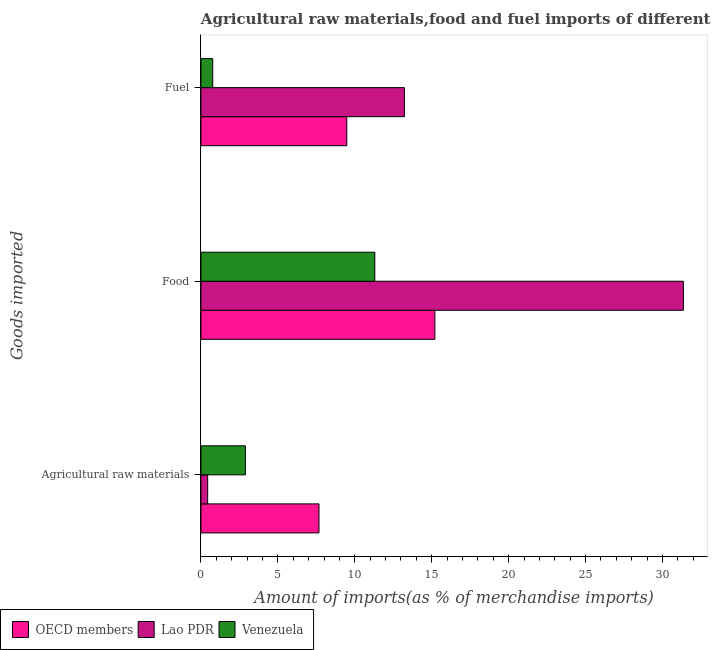How many different coloured bars are there?
Give a very brief answer. 3. How many groups of bars are there?
Give a very brief answer. 3. Are the number of bars per tick equal to the number of legend labels?
Ensure brevity in your answer.  Yes. How many bars are there on the 1st tick from the bottom?
Provide a short and direct response. 3. What is the label of the 1st group of bars from the top?
Provide a short and direct response. Fuel. What is the percentage of raw materials imports in OECD members?
Give a very brief answer. 7.67. Across all countries, what is the maximum percentage of food imports?
Keep it short and to the point. 31.35. Across all countries, what is the minimum percentage of raw materials imports?
Ensure brevity in your answer.  0.44. In which country was the percentage of food imports maximum?
Give a very brief answer. Lao PDR. In which country was the percentage of fuel imports minimum?
Make the answer very short. Venezuela. What is the total percentage of food imports in the graph?
Keep it short and to the point. 57.86. What is the difference between the percentage of fuel imports in Venezuela and that in Lao PDR?
Your answer should be very brief. -12.46. What is the difference between the percentage of raw materials imports in Venezuela and the percentage of fuel imports in OECD members?
Your answer should be compact. -6.59. What is the average percentage of raw materials imports per country?
Make the answer very short. 3.67. What is the difference between the percentage of raw materials imports and percentage of fuel imports in Lao PDR?
Your answer should be very brief. -12.79. In how many countries, is the percentage of food imports greater than 30 %?
Give a very brief answer. 1. What is the ratio of the percentage of food imports in OECD members to that in Venezuela?
Make the answer very short. 1.35. Is the difference between the percentage of fuel imports in Lao PDR and OECD members greater than the difference between the percentage of food imports in Lao PDR and OECD members?
Offer a very short reply. No. What is the difference between the highest and the second highest percentage of fuel imports?
Your answer should be compact. 3.75. What is the difference between the highest and the lowest percentage of fuel imports?
Your response must be concise. 12.46. In how many countries, is the percentage of food imports greater than the average percentage of food imports taken over all countries?
Offer a very short reply. 1. What does the 3rd bar from the bottom in Fuel represents?
Offer a very short reply. Venezuela. Is it the case that in every country, the sum of the percentage of raw materials imports and percentage of food imports is greater than the percentage of fuel imports?
Ensure brevity in your answer.  Yes. How many bars are there?
Your answer should be very brief. 9. Are the values on the major ticks of X-axis written in scientific E-notation?
Your answer should be compact. No. Does the graph contain any zero values?
Provide a short and direct response. No. Does the graph contain grids?
Give a very brief answer. No. How are the legend labels stacked?
Give a very brief answer. Horizontal. What is the title of the graph?
Give a very brief answer. Agricultural raw materials,food and fuel imports of different countries in 1969. Does "Ghana" appear as one of the legend labels in the graph?
Your answer should be compact. No. What is the label or title of the X-axis?
Your answer should be very brief. Amount of imports(as % of merchandise imports). What is the label or title of the Y-axis?
Provide a short and direct response. Goods imported. What is the Amount of imports(as % of merchandise imports) in OECD members in Agricultural raw materials?
Provide a succinct answer. 7.67. What is the Amount of imports(as % of merchandise imports) of Lao PDR in Agricultural raw materials?
Ensure brevity in your answer.  0.44. What is the Amount of imports(as % of merchandise imports) of Venezuela in Agricultural raw materials?
Keep it short and to the point. 2.89. What is the Amount of imports(as % of merchandise imports) of OECD members in Food?
Your answer should be compact. 15.21. What is the Amount of imports(as % of merchandise imports) in Lao PDR in Food?
Your answer should be very brief. 31.35. What is the Amount of imports(as % of merchandise imports) in Venezuela in Food?
Ensure brevity in your answer.  11.3. What is the Amount of imports(as % of merchandise imports) of OECD members in Fuel?
Your answer should be very brief. 9.48. What is the Amount of imports(as % of merchandise imports) in Lao PDR in Fuel?
Give a very brief answer. 13.23. What is the Amount of imports(as % of merchandise imports) in Venezuela in Fuel?
Make the answer very short. 0.77. Across all Goods imported, what is the maximum Amount of imports(as % of merchandise imports) of OECD members?
Provide a short and direct response. 15.21. Across all Goods imported, what is the maximum Amount of imports(as % of merchandise imports) in Lao PDR?
Your answer should be compact. 31.35. Across all Goods imported, what is the maximum Amount of imports(as % of merchandise imports) in Venezuela?
Keep it short and to the point. 11.3. Across all Goods imported, what is the minimum Amount of imports(as % of merchandise imports) in OECD members?
Offer a terse response. 7.67. Across all Goods imported, what is the minimum Amount of imports(as % of merchandise imports) of Lao PDR?
Ensure brevity in your answer.  0.44. Across all Goods imported, what is the minimum Amount of imports(as % of merchandise imports) in Venezuela?
Ensure brevity in your answer.  0.77. What is the total Amount of imports(as % of merchandise imports) of OECD members in the graph?
Provide a succinct answer. 32.36. What is the total Amount of imports(as % of merchandise imports) of Lao PDR in the graph?
Provide a short and direct response. 45.02. What is the total Amount of imports(as % of merchandise imports) in Venezuela in the graph?
Make the answer very short. 14.96. What is the difference between the Amount of imports(as % of merchandise imports) in OECD members in Agricultural raw materials and that in Food?
Ensure brevity in your answer.  -7.53. What is the difference between the Amount of imports(as % of merchandise imports) of Lao PDR in Agricultural raw materials and that in Food?
Offer a very short reply. -30.92. What is the difference between the Amount of imports(as % of merchandise imports) of Venezuela in Agricultural raw materials and that in Food?
Provide a short and direct response. -8.41. What is the difference between the Amount of imports(as % of merchandise imports) in OECD members in Agricultural raw materials and that in Fuel?
Your answer should be very brief. -1.81. What is the difference between the Amount of imports(as % of merchandise imports) of Lao PDR in Agricultural raw materials and that in Fuel?
Give a very brief answer. -12.79. What is the difference between the Amount of imports(as % of merchandise imports) in Venezuela in Agricultural raw materials and that in Fuel?
Your response must be concise. 2.12. What is the difference between the Amount of imports(as % of merchandise imports) of OECD members in Food and that in Fuel?
Your answer should be very brief. 5.72. What is the difference between the Amount of imports(as % of merchandise imports) in Lao PDR in Food and that in Fuel?
Give a very brief answer. 18.13. What is the difference between the Amount of imports(as % of merchandise imports) of Venezuela in Food and that in Fuel?
Ensure brevity in your answer.  10.53. What is the difference between the Amount of imports(as % of merchandise imports) of OECD members in Agricultural raw materials and the Amount of imports(as % of merchandise imports) of Lao PDR in Food?
Provide a succinct answer. -23.68. What is the difference between the Amount of imports(as % of merchandise imports) in OECD members in Agricultural raw materials and the Amount of imports(as % of merchandise imports) in Venezuela in Food?
Your answer should be very brief. -3.63. What is the difference between the Amount of imports(as % of merchandise imports) of Lao PDR in Agricultural raw materials and the Amount of imports(as % of merchandise imports) of Venezuela in Food?
Provide a short and direct response. -10.86. What is the difference between the Amount of imports(as % of merchandise imports) in OECD members in Agricultural raw materials and the Amount of imports(as % of merchandise imports) in Lao PDR in Fuel?
Your response must be concise. -5.55. What is the difference between the Amount of imports(as % of merchandise imports) in OECD members in Agricultural raw materials and the Amount of imports(as % of merchandise imports) in Venezuela in Fuel?
Ensure brevity in your answer.  6.9. What is the difference between the Amount of imports(as % of merchandise imports) in Lao PDR in Agricultural raw materials and the Amount of imports(as % of merchandise imports) in Venezuela in Fuel?
Keep it short and to the point. -0.33. What is the difference between the Amount of imports(as % of merchandise imports) of OECD members in Food and the Amount of imports(as % of merchandise imports) of Lao PDR in Fuel?
Ensure brevity in your answer.  1.98. What is the difference between the Amount of imports(as % of merchandise imports) of OECD members in Food and the Amount of imports(as % of merchandise imports) of Venezuela in Fuel?
Keep it short and to the point. 14.44. What is the difference between the Amount of imports(as % of merchandise imports) in Lao PDR in Food and the Amount of imports(as % of merchandise imports) in Venezuela in Fuel?
Your answer should be very brief. 30.59. What is the average Amount of imports(as % of merchandise imports) in OECD members per Goods imported?
Your answer should be very brief. 10.79. What is the average Amount of imports(as % of merchandise imports) in Lao PDR per Goods imported?
Make the answer very short. 15.01. What is the average Amount of imports(as % of merchandise imports) in Venezuela per Goods imported?
Keep it short and to the point. 4.99. What is the difference between the Amount of imports(as % of merchandise imports) in OECD members and Amount of imports(as % of merchandise imports) in Lao PDR in Agricultural raw materials?
Give a very brief answer. 7.24. What is the difference between the Amount of imports(as % of merchandise imports) in OECD members and Amount of imports(as % of merchandise imports) in Venezuela in Agricultural raw materials?
Your answer should be compact. 4.78. What is the difference between the Amount of imports(as % of merchandise imports) of Lao PDR and Amount of imports(as % of merchandise imports) of Venezuela in Agricultural raw materials?
Keep it short and to the point. -2.45. What is the difference between the Amount of imports(as % of merchandise imports) of OECD members and Amount of imports(as % of merchandise imports) of Lao PDR in Food?
Offer a terse response. -16.15. What is the difference between the Amount of imports(as % of merchandise imports) in OECD members and Amount of imports(as % of merchandise imports) in Venezuela in Food?
Offer a very short reply. 3.9. What is the difference between the Amount of imports(as % of merchandise imports) in Lao PDR and Amount of imports(as % of merchandise imports) in Venezuela in Food?
Your response must be concise. 20.05. What is the difference between the Amount of imports(as % of merchandise imports) in OECD members and Amount of imports(as % of merchandise imports) in Lao PDR in Fuel?
Your response must be concise. -3.75. What is the difference between the Amount of imports(as % of merchandise imports) in OECD members and Amount of imports(as % of merchandise imports) in Venezuela in Fuel?
Make the answer very short. 8.71. What is the difference between the Amount of imports(as % of merchandise imports) in Lao PDR and Amount of imports(as % of merchandise imports) in Venezuela in Fuel?
Your answer should be very brief. 12.46. What is the ratio of the Amount of imports(as % of merchandise imports) in OECD members in Agricultural raw materials to that in Food?
Offer a terse response. 0.5. What is the ratio of the Amount of imports(as % of merchandise imports) in Lao PDR in Agricultural raw materials to that in Food?
Your response must be concise. 0.01. What is the ratio of the Amount of imports(as % of merchandise imports) in Venezuela in Agricultural raw materials to that in Food?
Your response must be concise. 0.26. What is the ratio of the Amount of imports(as % of merchandise imports) in OECD members in Agricultural raw materials to that in Fuel?
Your answer should be very brief. 0.81. What is the ratio of the Amount of imports(as % of merchandise imports) of Lao PDR in Agricultural raw materials to that in Fuel?
Make the answer very short. 0.03. What is the ratio of the Amount of imports(as % of merchandise imports) in Venezuela in Agricultural raw materials to that in Fuel?
Make the answer very short. 3.76. What is the ratio of the Amount of imports(as % of merchandise imports) of OECD members in Food to that in Fuel?
Make the answer very short. 1.6. What is the ratio of the Amount of imports(as % of merchandise imports) of Lao PDR in Food to that in Fuel?
Keep it short and to the point. 2.37. What is the ratio of the Amount of imports(as % of merchandise imports) in Venezuela in Food to that in Fuel?
Ensure brevity in your answer.  14.69. What is the difference between the highest and the second highest Amount of imports(as % of merchandise imports) of OECD members?
Offer a terse response. 5.72. What is the difference between the highest and the second highest Amount of imports(as % of merchandise imports) in Lao PDR?
Keep it short and to the point. 18.13. What is the difference between the highest and the second highest Amount of imports(as % of merchandise imports) in Venezuela?
Provide a short and direct response. 8.41. What is the difference between the highest and the lowest Amount of imports(as % of merchandise imports) in OECD members?
Provide a short and direct response. 7.53. What is the difference between the highest and the lowest Amount of imports(as % of merchandise imports) in Lao PDR?
Keep it short and to the point. 30.92. What is the difference between the highest and the lowest Amount of imports(as % of merchandise imports) in Venezuela?
Ensure brevity in your answer.  10.53. 